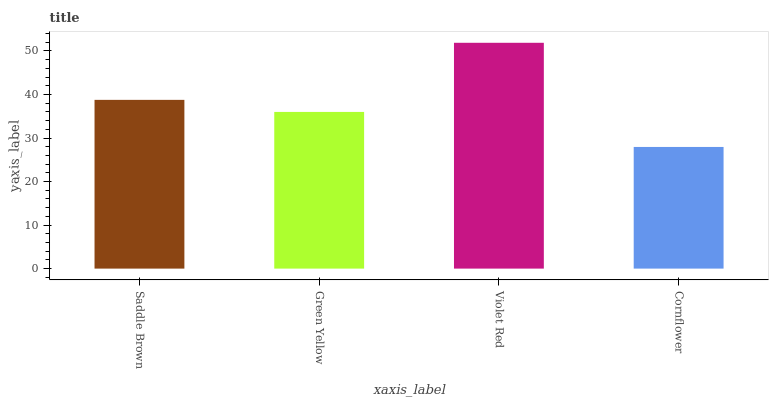Is Green Yellow the minimum?
Answer yes or no. No. Is Green Yellow the maximum?
Answer yes or no. No. Is Saddle Brown greater than Green Yellow?
Answer yes or no. Yes. Is Green Yellow less than Saddle Brown?
Answer yes or no. Yes. Is Green Yellow greater than Saddle Brown?
Answer yes or no. No. Is Saddle Brown less than Green Yellow?
Answer yes or no. No. Is Saddle Brown the high median?
Answer yes or no. Yes. Is Green Yellow the low median?
Answer yes or no. Yes. Is Cornflower the high median?
Answer yes or no. No. Is Violet Red the low median?
Answer yes or no. No. 